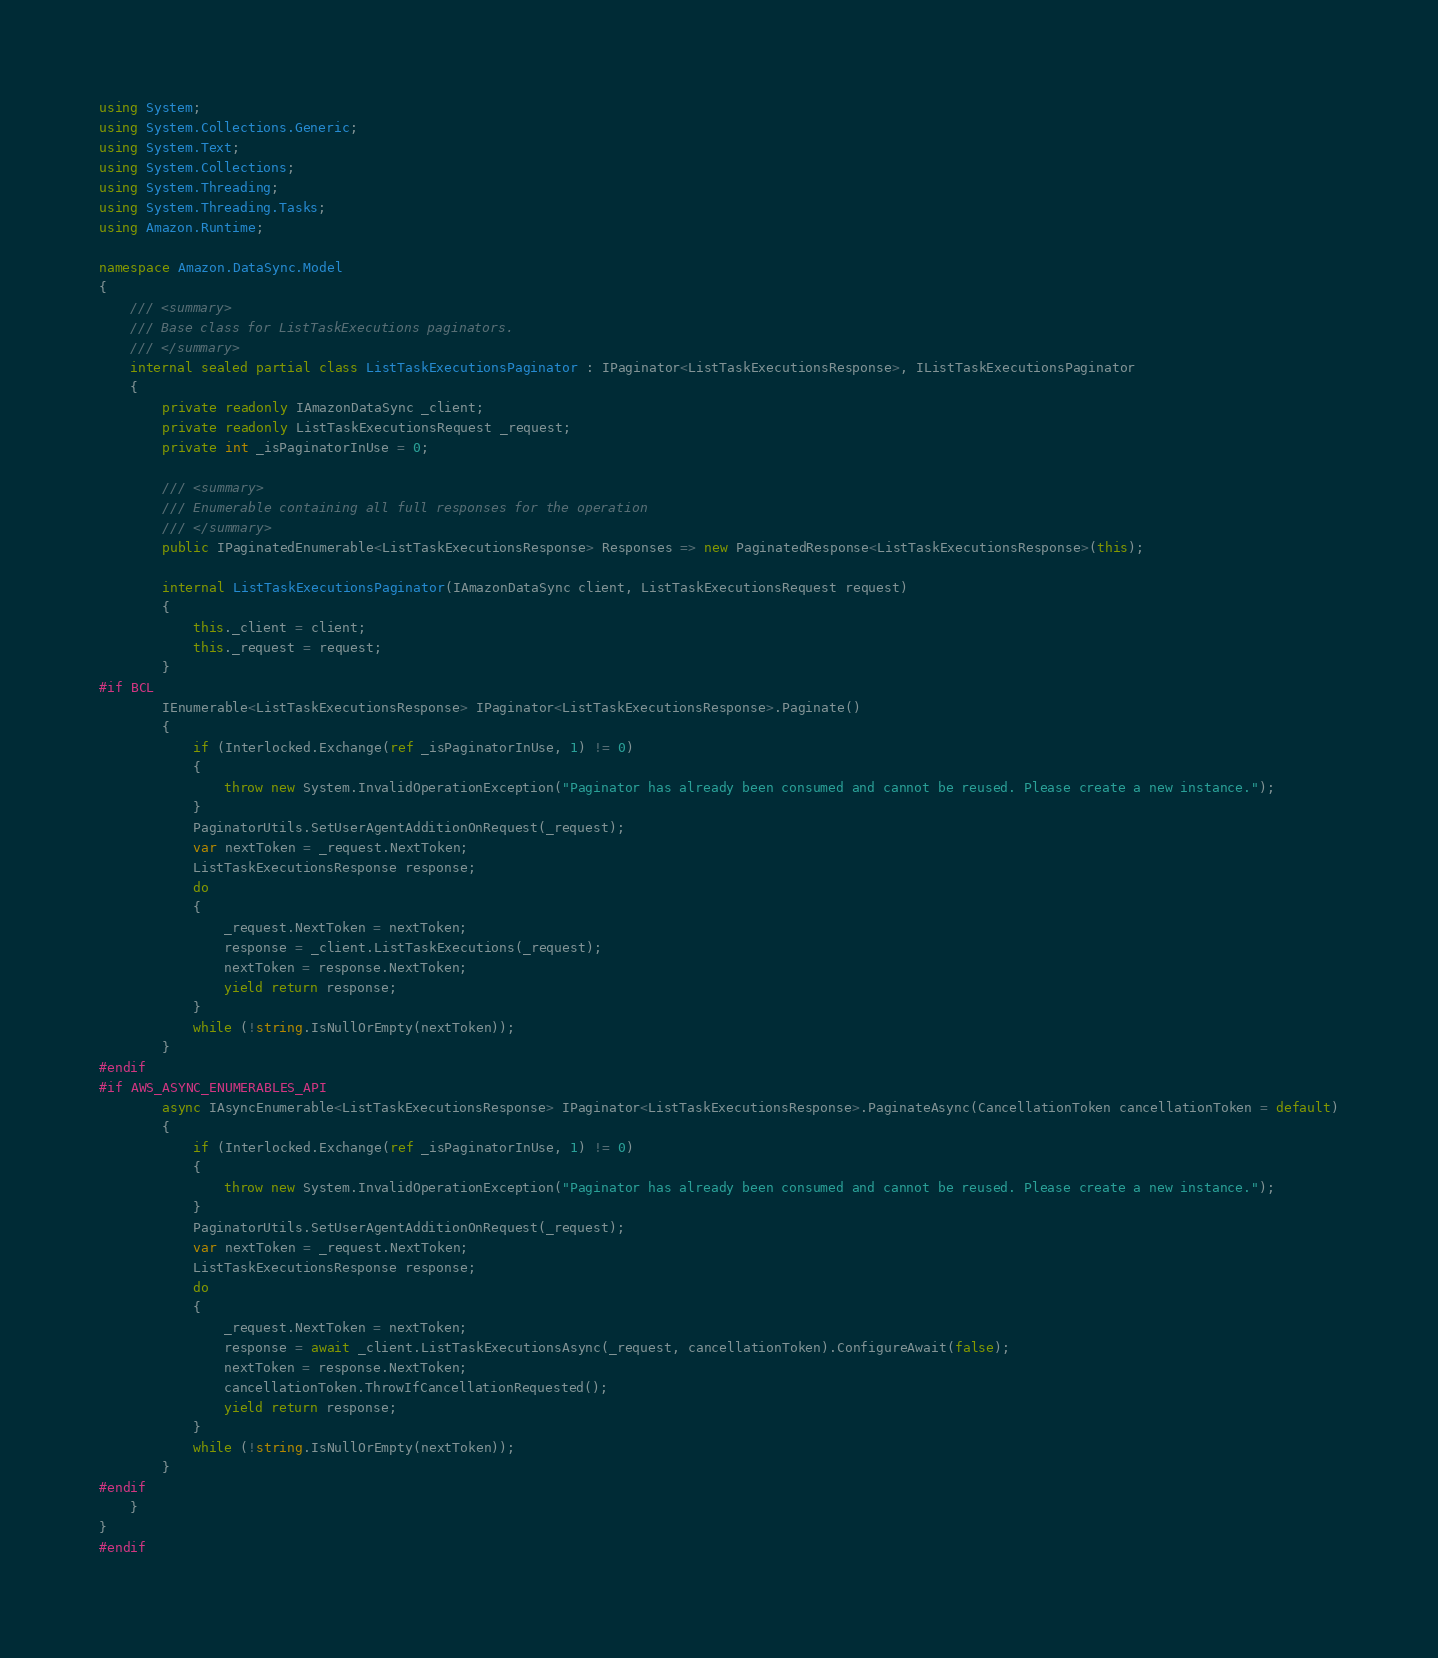<code> <loc_0><loc_0><loc_500><loc_500><_C#_>using System;
using System.Collections.Generic;
using System.Text;
using System.Collections;
using System.Threading;
using System.Threading.Tasks;
using Amazon.Runtime;
 
namespace Amazon.DataSync.Model
{
    /// <summary>
    /// Base class for ListTaskExecutions paginators.
    /// </summary>
    internal sealed partial class ListTaskExecutionsPaginator : IPaginator<ListTaskExecutionsResponse>, IListTaskExecutionsPaginator
    {
        private readonly IAmazonDataSync _client;
        private readonly ListTaskExecutionsRequest _request;
        private int _isPaginatorInUse = 0;
        
        /// <summary>
        /// Enumerable containing all full responses for the operation
        /// </summary>
        public IPaginatedEnumerable<ListTaskExecutionsResponse> Responses => new PaginatedResponse<ListTaskExecutionsResponse>(this);

        internal ListTaskExecutionsPaginator(IAmazonDataSync client, ListTaskExecutionsRequest request)
        {
            this._client = client;
            this._request = request;
        }
#if BCL
        IEnumerable<ListTaskExecutionsResponse> IPaginator<ListTaskExecutionsResponse>.Paginate()
        {
            if (Interlocked.Exchange(ref _isPaginatorInUse, 1) != 0)
            {
                throw new System.InvalidOperationException("Paginator has already been consumed and cannot be reused. Please create a new instance.");
            }
            PaginatorUtils.SetUserAgentAdditionOnRequest(_request);
            var nextToken = _request.NextToken;
            ListTaskExecutionsResponse response;
            do
            {
                _request.NextToken = nextToken;
                response = _client.ListTaskExecutions(_request);
                nextToken = response.NextToken;
                yield return response;
            }
            while (!string.IsNullOrEmpty(nextToken));
        }
#endif
#if AWS_ASYNC_ENUMERABLES_API
        async IAsyncEnumerable<ListTaskExecutionsResponse> IPaginator<ListTaskExecutionsResponse>.PaginateAsync(CancellationToken cancellationToken = default)
        {
            if (Interlocked.Exchange(ref _isPaginatorInUse, 1) != 0)
            {
                throw new System.InvalidOperationException("Paginator has already been consumed and cannot be reused. Please create a new instance.");
            }
            PaginatorUtils.SetUserAgentAdditionOnRequest(_request);
            var nextToken = _request.NextToken;
            ListTaskExecutionsResponse response;
            do
            {
                _request.NextToken = nextToken;
                response = await _client.ListTaskExecutionsAsync(_request, cancellationToken).ConfigureAwait(false);
                nextToken = response.NextToken;
                cancellationToken.ThrowIfCancellationRequested();
                yield return response;
            }
            while (!string.IsNullOrEmpty(nextToken));
        }
#endif
    }
}
#endif</code> 